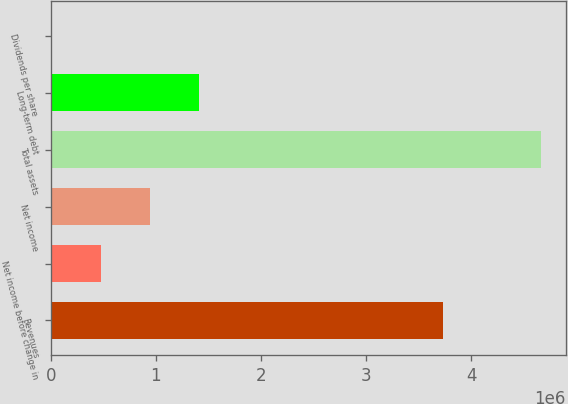<chart> <loc_0><loc_0><loc_500><loc_500><bar_chart><fcel>Revenues<fcel>Net income before change in<fcel>Net income<fcel>Total assets<fcel>Long-term debt<fcel>Dividends per share<nl><fcel>3.73113e+06<fcel>477615<fcel>944265<fcel>4.6665e+06<fcel>1.41092e+06<fcel>0.35<nl></chart> 